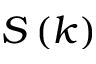<formula> <loc_0><loc_0><loc_500><loc_500>S \left ( k \right )</formula> 